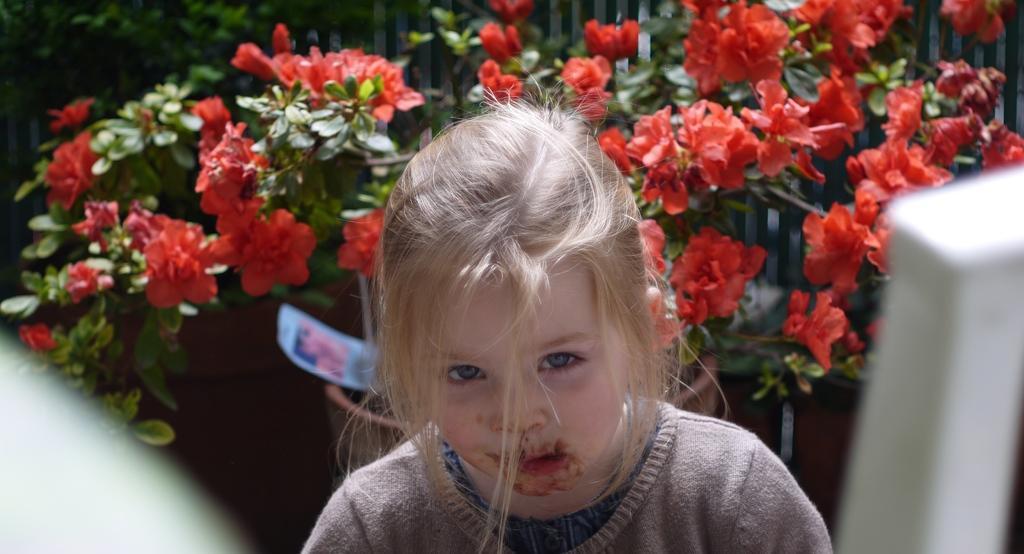Could you give a brief overview of what you see in this image? In this image there is one kid in middle of this image and there are some plants with some flowers in the background. 